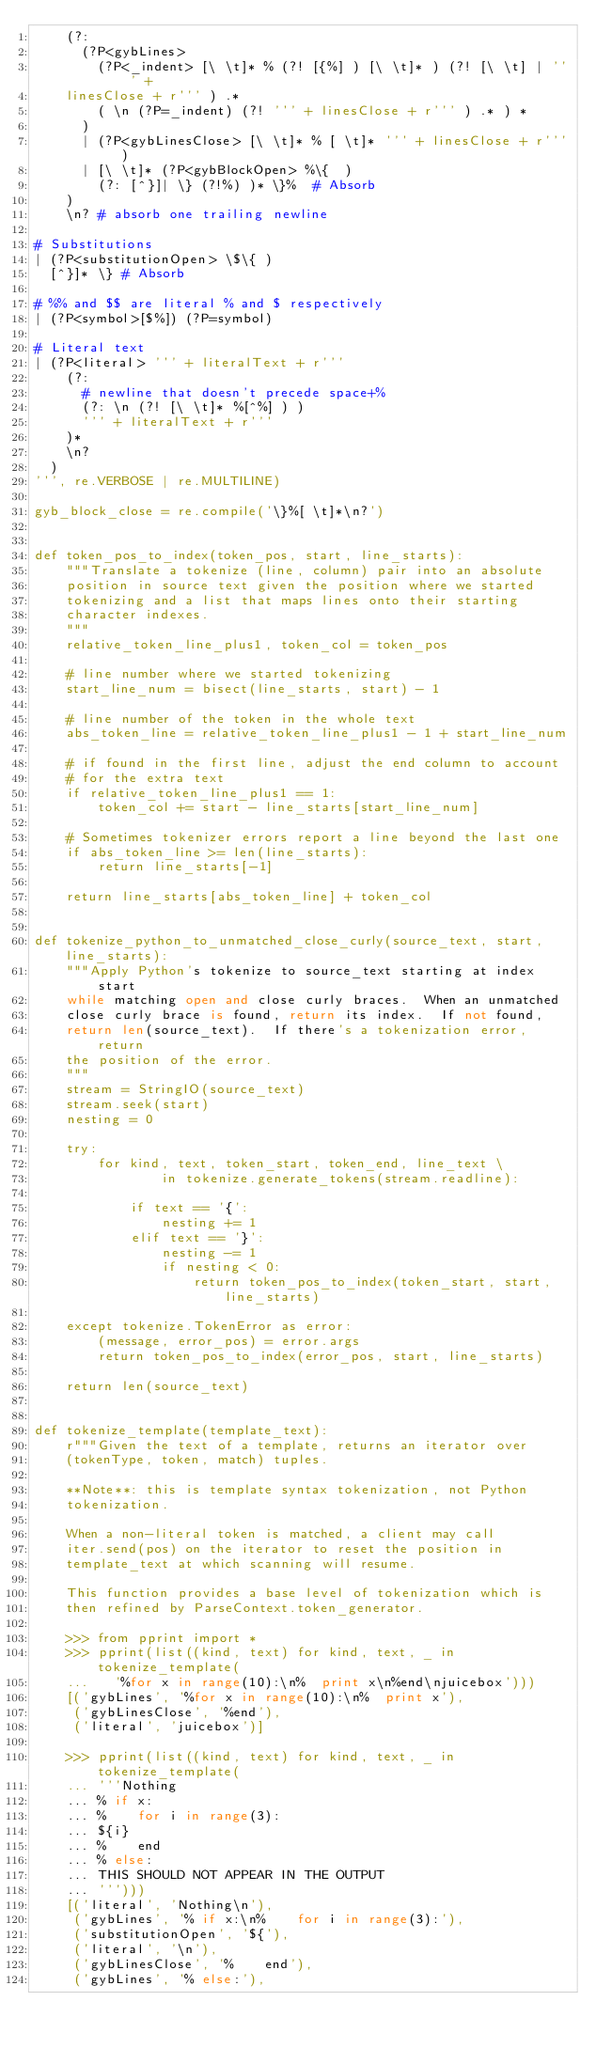Convert code to text. <code><loc_0><loc_0><loc_500><loc_500><_Python_>    (?:
      (?P<gybLines>
        (?P<_indent> [\ \t]* % (?! [{%] ) [\ \t]* ) (?! [\ \t] | ''' +
    linesClose + r''' ) .*
        ( \n (?P=_indent) (?! ''' + linesClose + r''' ) .* ) *
      )
      | (?P<gybLinesClose> [\ \t]* % [ \t]* ''' + linesClose + r''' )
      | [\ \t]* (?P<gybBlockOpen> %\{  )
        (?: [^}]| \} (?!%) )* \}%  # Absorb
    )
    \n? # absorb one trailing newline

# Substitutions
| (?P<substitutionOpen> \$\{ )
  [^}]* \} # Absorb

# %% and $$ are literal % and $ respectively
| (?P<symbol>[$%]) (?P=symbol)

# Literal text
| (?P<literal> ''' + literalText + r'''
    (?:
      # newline that doesn't precede space+%
      (?: \n (?! [\ \t]* %[^%] ) )
      ''' + literalText + r'''
    )*
    \n?
  )
''', re.VERBOSE | re.MULTILINE)

gyb_block_close = re.compile('\}%[ \t]*\n?')


def token_pos_to_index(token_pos, start, line_starts):
    """Translate a tokenize (line, column) pair into an absolute
    position in source text given the position where we started
    tokenizing and a list that maps lines onto their starting
    character indexes.
    """
    relative_token_line_plus1, token_col = token_pos

    # line number where we started tokenizing
    start_line_num = bisect(line_starts, start) - 1

    # line number of the token in the whole text
    abs_token_line = relative_token_line_plus1 - 1 + start_line_num

    # if found in the first line, adjust the end column to account
    # for the extra text
    if relative_token_line_plus1 == 1:
        token_col += start - line_starts[start_line_num]

    # Sometimes tokenizer errors report a line beyond the last one
    if abs_token_line >= len(line_starts):
        return line_starts[-1]

    return line_starts[abs_token_line] + token_col


def tokenize_python_to_unmatched_close_curly(source_text, start, line_starts):
    """Apply Python's tokenize to source_text starting at index start
    while matching open and close curly braces.  When an unmatched
    close curly brace is found, return its index.  If not found,
    return len(source_text).  If there's a tokenization error, return
    the position of the error.
    """
    stream = StringIO(source_text)
    stream.seek(start)
    nesting = 0

    try:
        for kind, text, token_start, token_end, line_text \
                in tokenize.generate_tokens(stream.readline):

            if text == '{':
                nesting += 1
            elif text == '}':
                nesting -= 1
                if nesting < 0:
                    return token_pos_to_index(token_start, start, line_starts)

    except tokenize.TokenError as error:
        (message, error_pos) = error.args
        return token_pos_to_index(error_pos, start, line_starts)

    return len(source_text)


def tokenize_template(template_text):
    r"""Given the text of a template, returns an iterator over
    (tokenType, token, match) tuples.

    **Note**: this is template syntax tokenization, not Python
    tokenization.

    When a non-literal token is matched, a client may call
    iter.send(pos) on the iterator to reset the position in
    template_text at which scanning will resume.

    This function provides a base level of tokenization which is
    then refined by ParseContext.token_generator.

    >>> from pprint import *
    >>> pprint(list((kind, text) for kind, text, _ in tokenize_template(
    ...   '%for x in range(10):\n%  print x\n%end\njuicebox')))
    [('gybLines', '%for x in range(10):\n%  print x'),
     ('gybLinesClose', '%end'),
     ('literal', 'juicebox')]

    >>> pprint(list((kind, text) for kind, text, _ in tokenize_template(
    ... '''Nothing
    ... % if x:
    ... %    for i in range(3):
    ... ${i}
    ... %    end
    ... % else:
    ... THIS SHOULD NOT APPEAR IN THE OUTPUT
    ... ''')))
    [('literal', 'Nothing\n'),
     ('gybLines', '% if x:\n%    for i in range(3):'),
     ('substitutionOpen', '${'),
     ('literal', '\n'),
     ('gybLinesClose', '%    end'),
     ('gybLines', '% else:'),</code> 